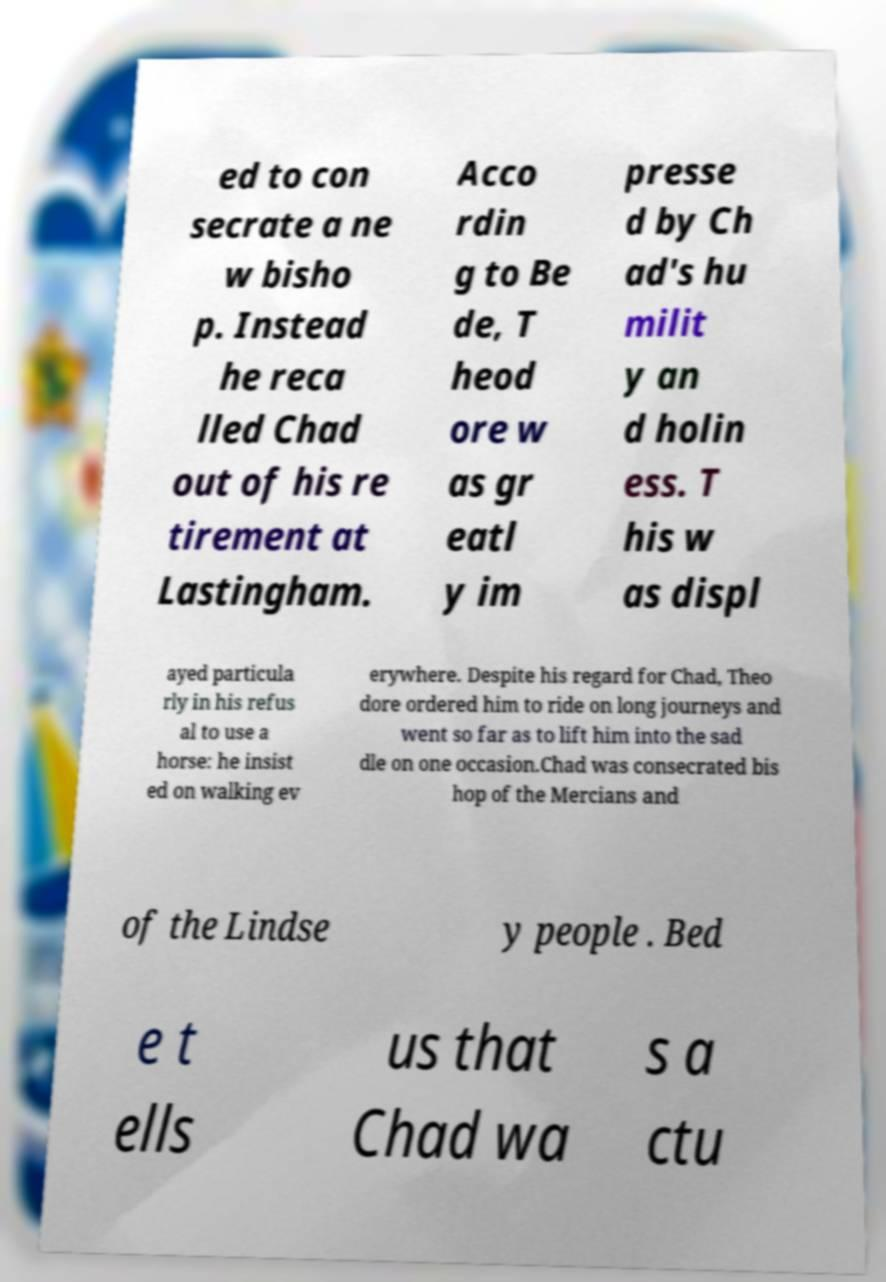Could you extract and type out the text from this image? ed to con secrate a ne w bisho p. Instead he reca lled Chad out of his re tirement at Lastingham. Acco rdin g to Be de, T heod ore w as gr eatl y im presse d by Ch ad's hu milit y an d holin ess. T his w as displ ayed particula rly in his refus al to use a horse: he insist ed on walking ev erywhere. Despite his regard for Chad, Theo dore ordered him to ride on long journeys and went so far as to lift him into the sad dle on one occasion.Chad was consecrated bis hop of the Mercians and of the Lindse y people . Bed e t ells us that Chad wa s a ctu 